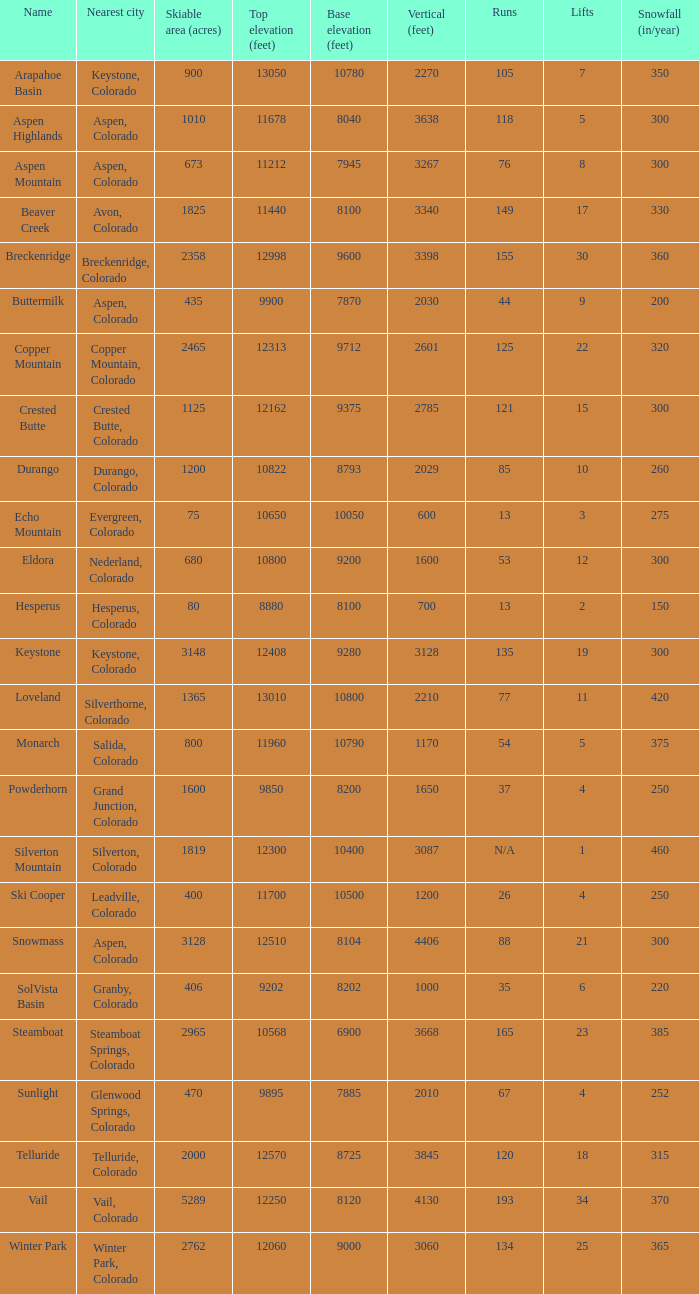With 11 lifts present, what is the fundamental elevation? 10800.0. 